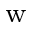Convert formula to latex. <formula><loc_0><loc_0><loc_500><loc_500>_ { w }</formula> 